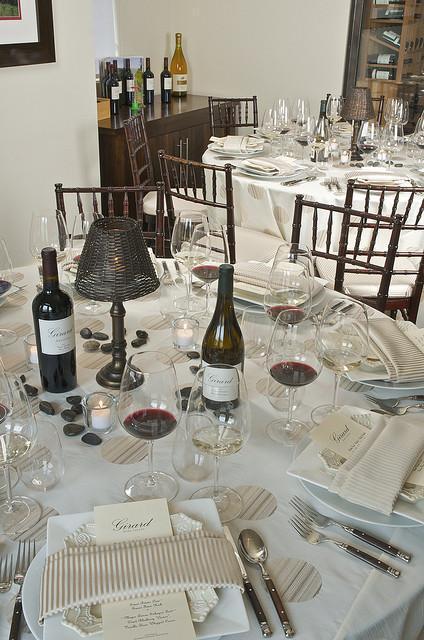How many forks are at each place setting?
Give a very brief answer. 2. How many bottles are in the picture?
Give a very brief answer. 2. How many dining tables can you see?
Give a very brief answer. 2. How many wine glasses can you see?
Give a very brief answer. 8. How many chairs are in the photo?
Give a very brief answer. 4. How many people in this image are wearing a white jacket?
Give a very brief answer. 0. 